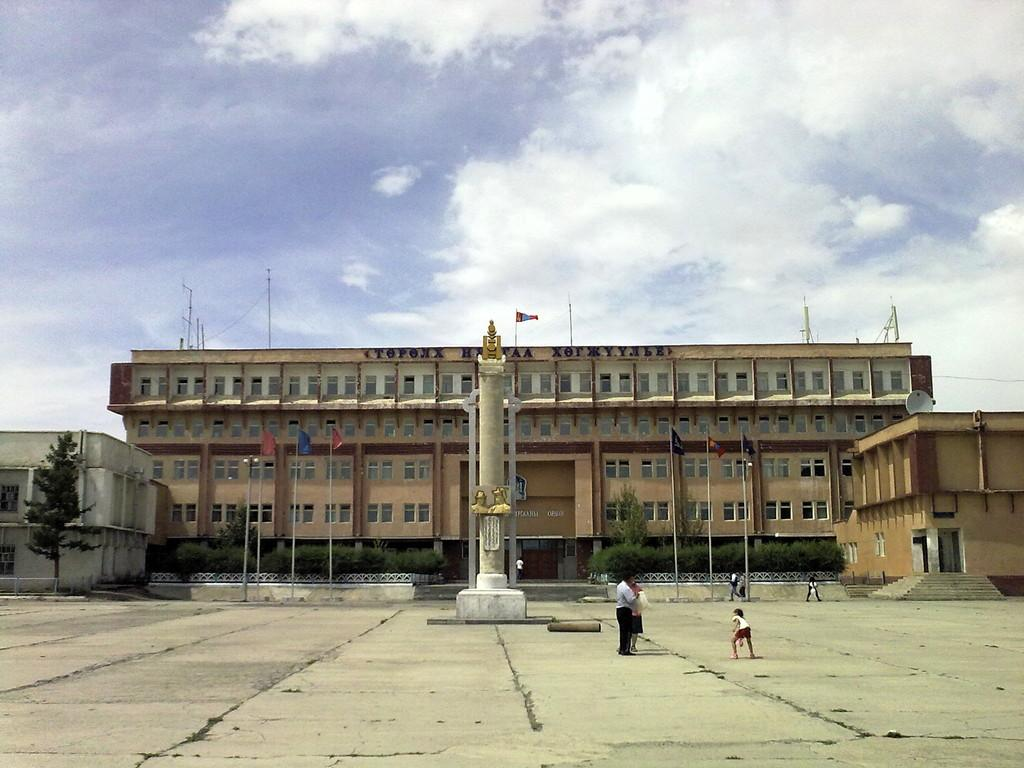What is the main structure in the image? There is a big building in the image. What is on top of the building? The building has a flag on top. What is located in front of the building? There is a tower in front of the building. What can be seen on the ground in the image? People are walking on the ground in the image. What type of feast is being prepared in the image? There is no indication of a feast being prepared in the image; it primarily features a big building, a flag, a tower, and people walking on the ground. 